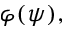<formula> <loc_0><loc_0><loc_500><loc_500>\varphi ( \psi ) ,</formula> 